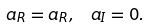Convert formula to latex. <formula><loc_0><loc_0><loc_500><loc_500>\ a _ { R } = a _ { R } , \, \ a _ { I } = 0 .</formula> 